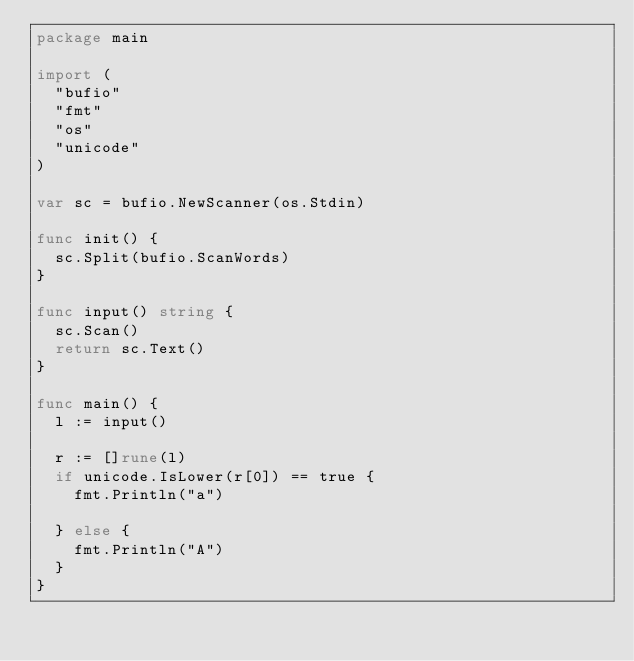Convert code to text. <code><loc_0><loc_0><loc_500><loc_500><_Go_>package main

import (
	"bufio"
	"fmt"
	"os"
	"unicode"
)

var sc = bufio.NewScanner(os.Stdin)

func init() {
	sc.Split(bufio.ScanWords)
}

func input() string {
	sc.Scan()
	return sc.Text()
}

func main() {
	l := input()

	r := []rune(l)
	if unicode.IsLower(r[0]) == true {
		fmt.Println("a")

	} else {
		fmt.Println("A")
	}
}
</code> 